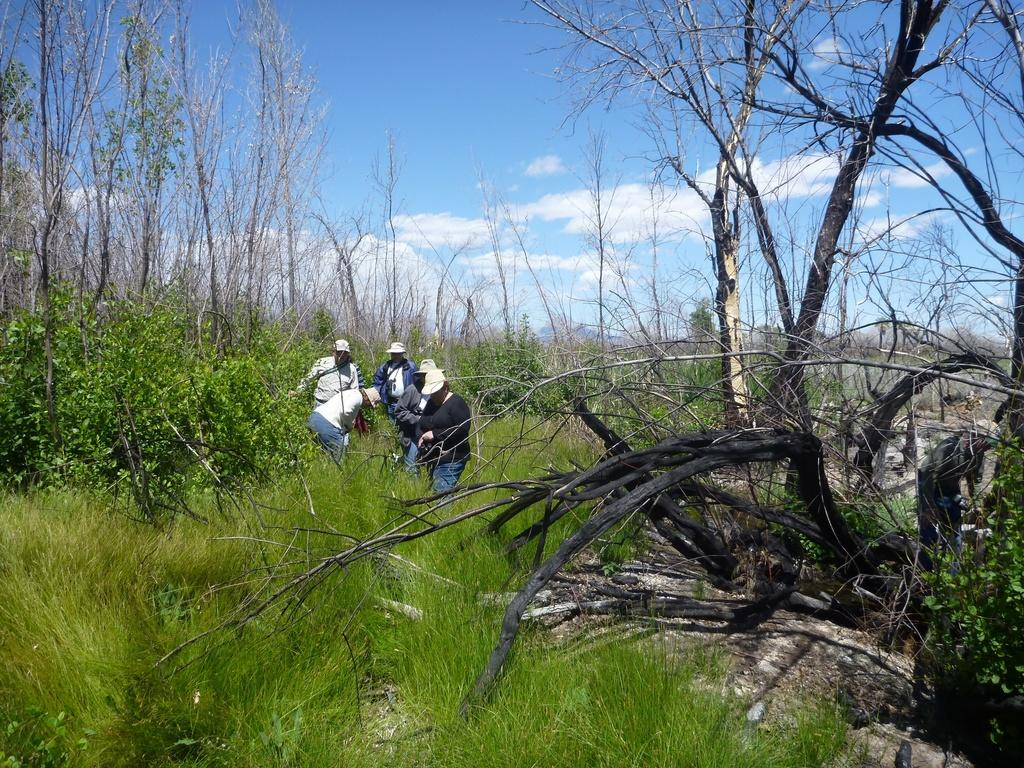What type of surface is visible on the ground in the image? There is grass on the ground in the image. What can be seen in the center of the image? There are persons standing in the center of the image. What type of vegetation is visible in the background of the image? There are trees in the background of the image. How would you describe the sky in the image? The sky is cloudy in the image. What type of glass is being used to enhance the flavor of the trees in the image? There is no glass or flavor enhancement present in the image; it features grass, persons, trees, and a cloudy sky. 